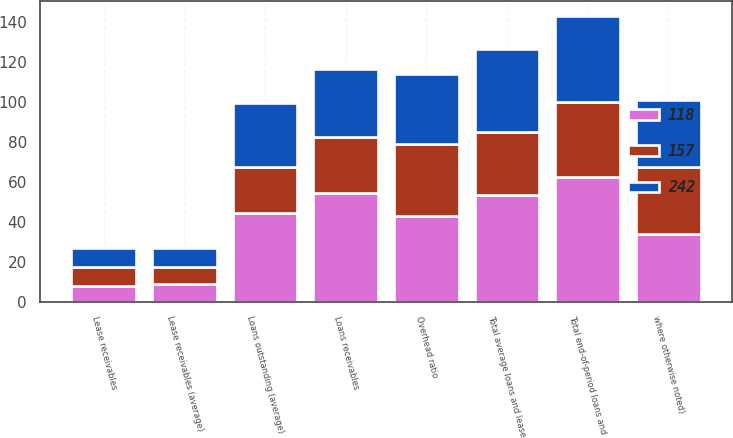Convert chart to OTSL. <chart><loc_0><loc_0><loc_500><loc_500><stacked_bar_chart><ecel><fcel>where otherwise noted)<fcel>Loans receivables<fcel>Lease receivables<fcel>Total end-of-period loans and<fcel>Loans outstanding (average)<fcel>Lease receivables (average)<fcel>Total average loans and lease<fcel>Overhead ratio<nl><fcel>118<fcel>33.7<fcel>54.6<fcel>8<fcel>62.6<fcel>44.3<fcel>9<fcel>53.3<fcel>43<nl><fcel>242<fcel>33.7<fcel>33.7<fcel>9.5<fcel>43.2<fcel>32<fcel>9.7<fcel>41.7<fcel>35<nl><fcel>157<fcel>33.7<fcel>28<fcel>9.4<fcel>37.4<fcel>23.3<fcel>8.4<fcel>31.7<fcel>36<nl></chart> 